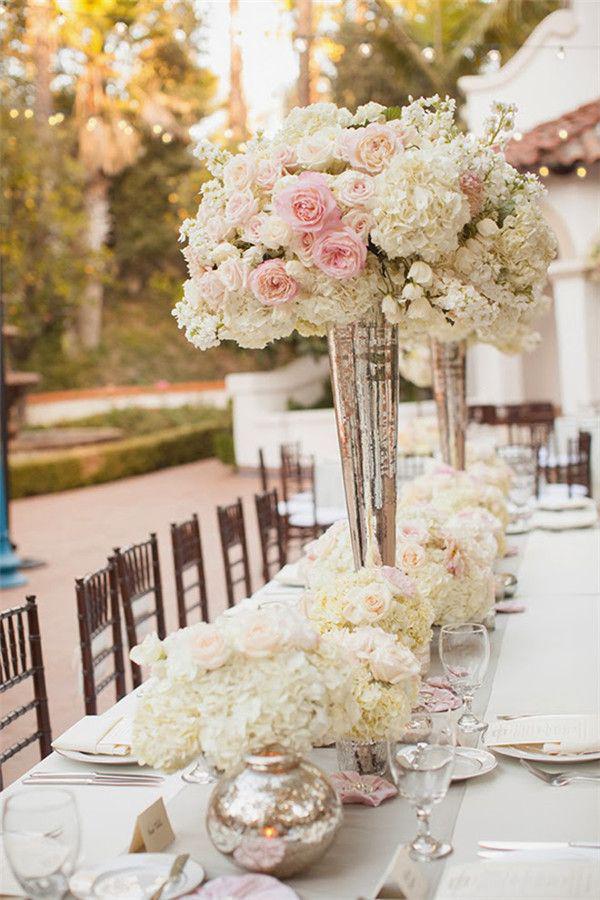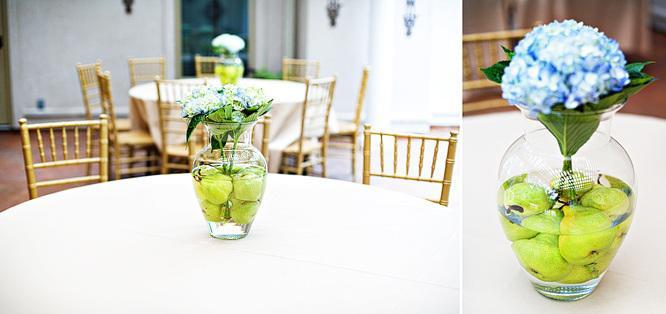The first image is the image on the left, the second image is the image on the right. For the images shown, is this caption "Two clear vases with green fruit in their water-filled bases are shown in the right image." true? Answer yes or no. Yes. The first image is the image on the left, the second image is the image on the right. Analyze the images presented: Is the assertion "The vases in the left image are silver colored." valid? Answer yes or no. Yes. 